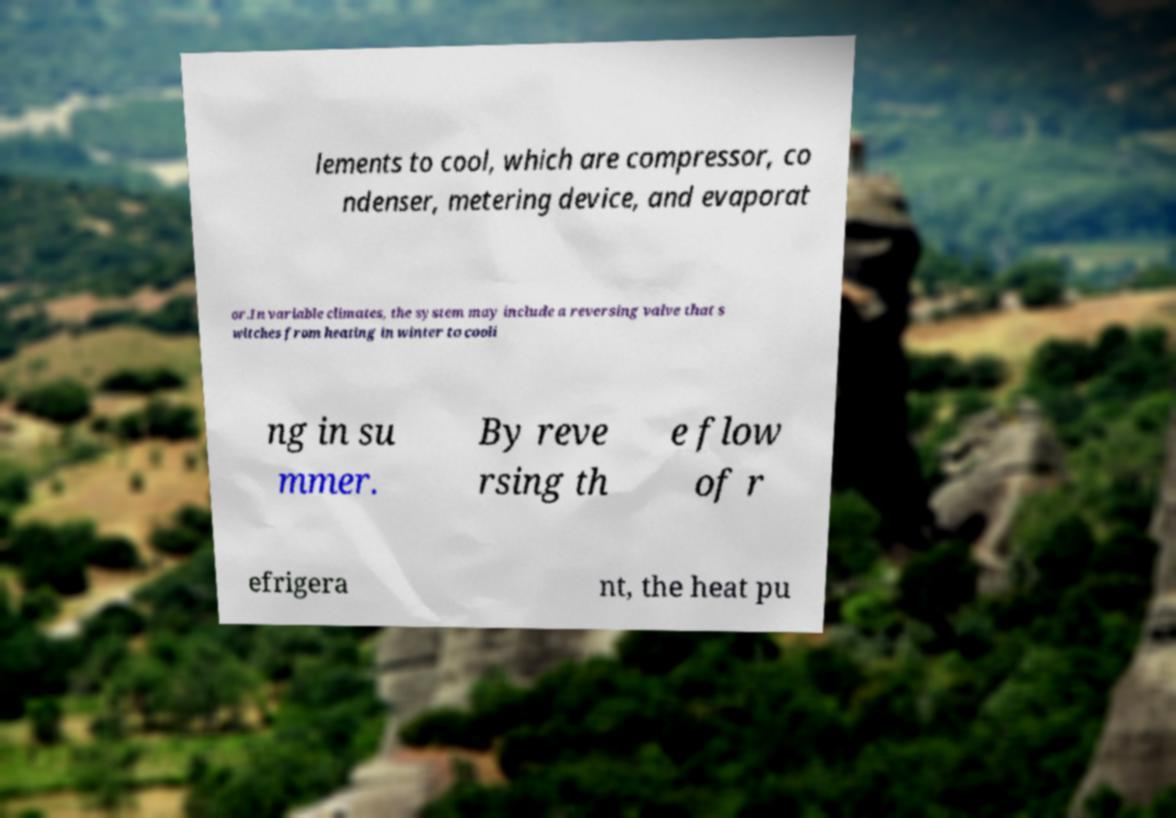Please identify and transcribe the text found in this image. lements to cool, which are compressor, co ndenser, metering device, and evaporat or.In variable climates, the system may include a reversing valve that s witches from heating in winter to cooli ng in su mmer. By reve rsing th e flow of r efrigera nt, the heat pu 